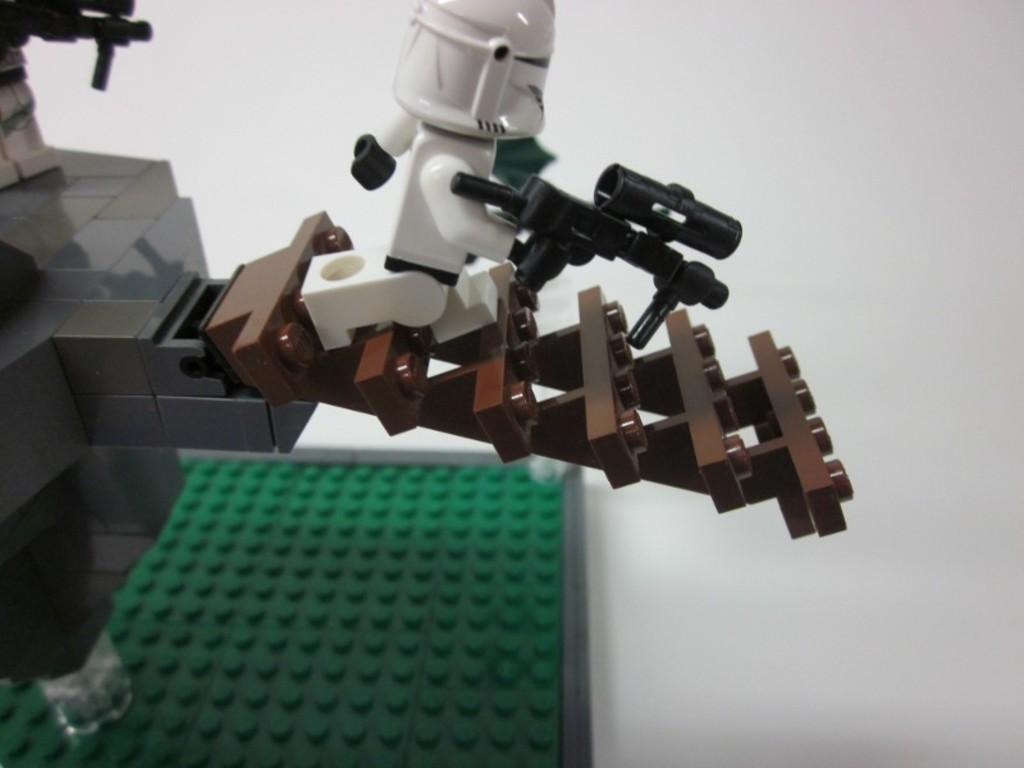In one or two sentences, can you explain what this image depicts? In the image there is a robot toy on a lego building, on a table. 